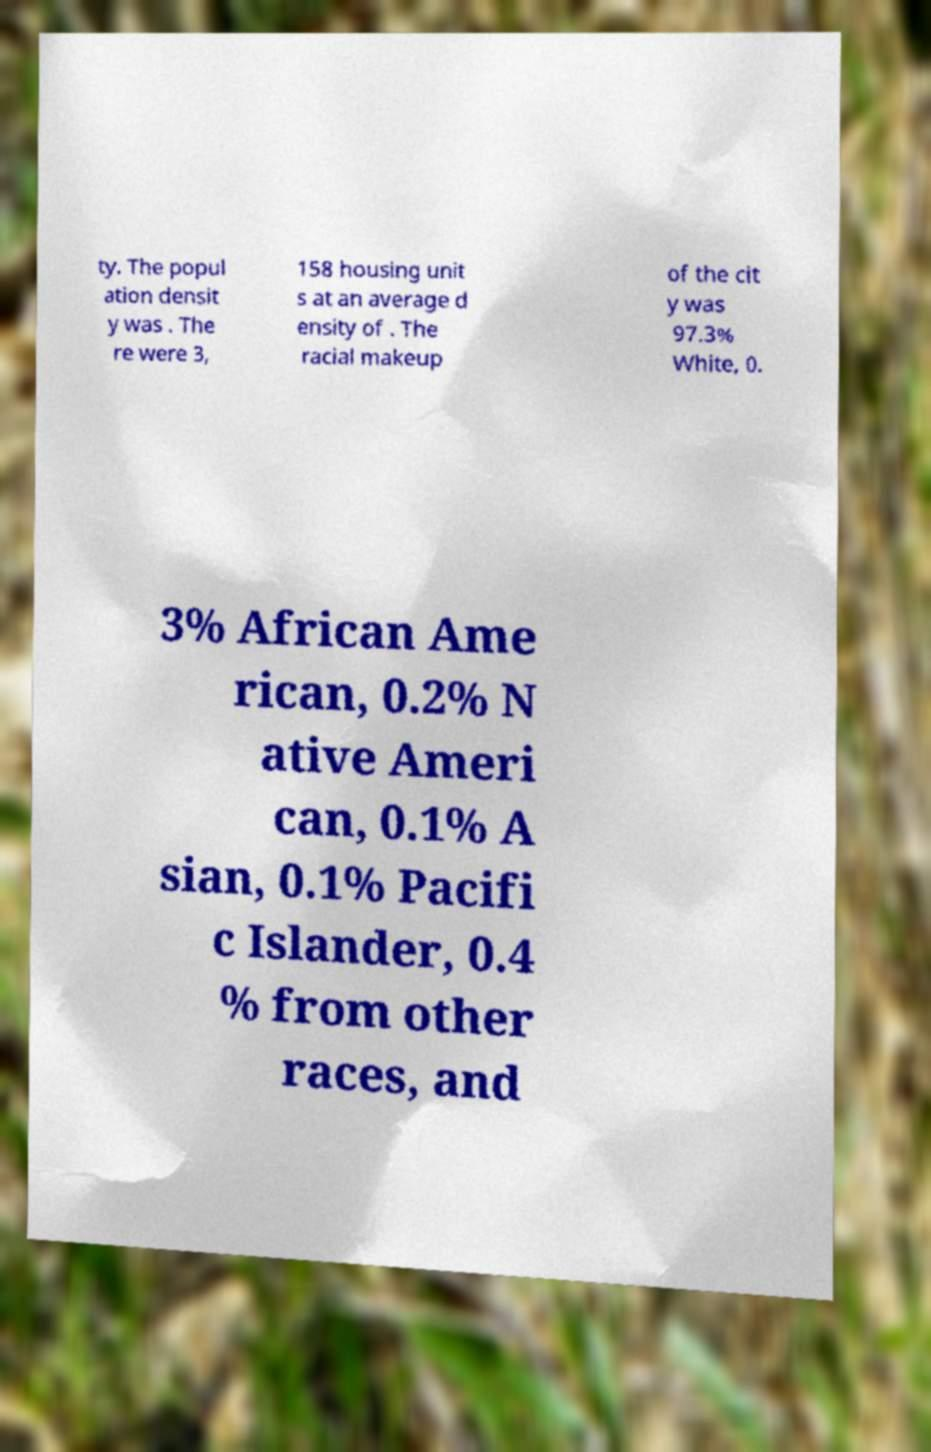For documentation purposes, I need the text within this image transcribed. Could you provide that? ty. The popul ation densit y was . The re were 3, 158 housing unit s at an average d ensity of . The racial makeup of the cit y was 97.3% White, 0. 3% African Ame rican, 0.2% N ative Ameri can, 0.1% A sian, 0.1% Pacifi c Islander, 0.4 % from other races, and 